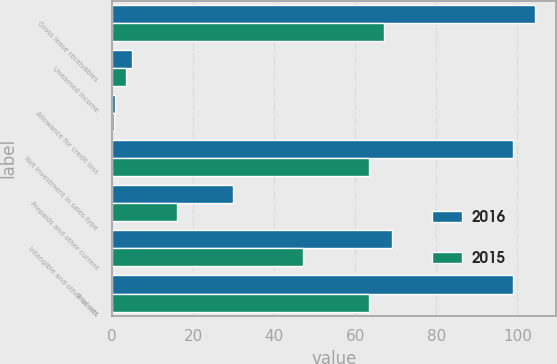<chart> <loc_0><loc_0><loc_500><loc_500><stacked_bar_chart><ecel><fcel>Gross lease receivables<fcel>Unearned income<fcel>Allowance for credit loss<fcel>Net investment in sales-type<fcel>Prepaids and other current<fcel>Intangible and other assets<fcel>Total net<nl><fcel>2016<fcel>104.3<fcel>4.8<fcel>0.6<fcel>98.9<fcel>29.8<fcel>69.1<fcel>98.9<nl><fcel>2015<fcel>67.1<fcel>3.4<fcel>0.4<fcel>63.3<fcel>16.1<fcel>47.2<fcel>63.3<nl></chart> 